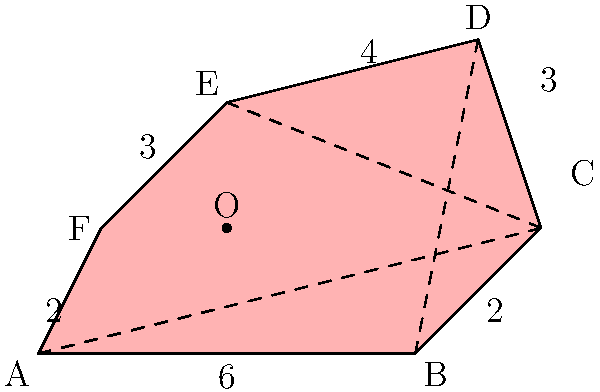As an expatriate in Suriname, you are asked to calculate the area of an irregular quarantine zone in Paramaribo. The zone is represented by the polygon ABCDEF on the map, where each unit represents 100 meters. Given that point O (3,2) is inside the polygon, determine the area of the quarantine zone in square kilometers. To find the area of the irregular polygon, we can use the triangulation method:

1) Divide the polygon into triangles by connecting point O to all vertices.

2) Calculate the areas of these triangles using the formula:
   $A = \frac{1}{2}|x_1(y_2 - y_3) + x_2(y_3 - y_1) + x_3(y_1 - y_2)|$

3) Sum up all the triangle areas:

   Triangle AOB: $\frac{1}{2}|3(0 - 0) + 6(2 - 0) + 0(0 - 2)| = 6$
   Triangle BOC: $\frac{1}{2}|3(0 - 2) + 8(2 - 0) + 6(0 - 2)| = 5$
   Triangle COD: $\frac{1}{2}|3(2 - 5) + 8(5 - 2) + 7(2 - 5)| = 7.5$
   Triangle DOE: $\frac{1}{2}|3(5 - 4) + 7(4 - 2) + 3(2 - 5)| = 6$
   Triangle EOF: $\frac{1}{2}|3(4 - 2) + 3(2 - 2) + 1(2 - 4)| = 3$
   Triangle FOA: $\frac{1}{2}|3(2 - 0) + 1(0 - 2) + 0(2 - 0)| = 2$

4) Total area = 6 + 5 + 7.5 + 6 + 3 + 2 = 29.5 square units

5) Convert to square kilometers:
   29.5 * (100m * 100m) = 295,000 sq m = 0.295 sq km

Therefore, the area of the quarantine zone is 0.295 square kilometers.
Answer: 0.295 sq km 